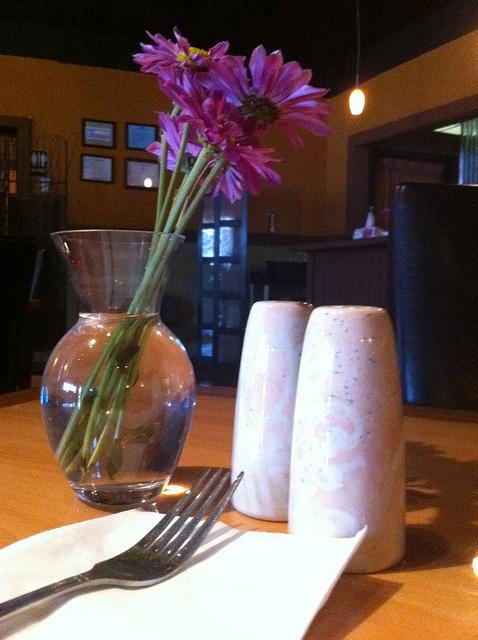Are there flowers on the table?
Answer briefly. Yes. How many forks are there?
Give a very brief answer. 1. Is this a restaurant?
Keep it brief. Yes. 